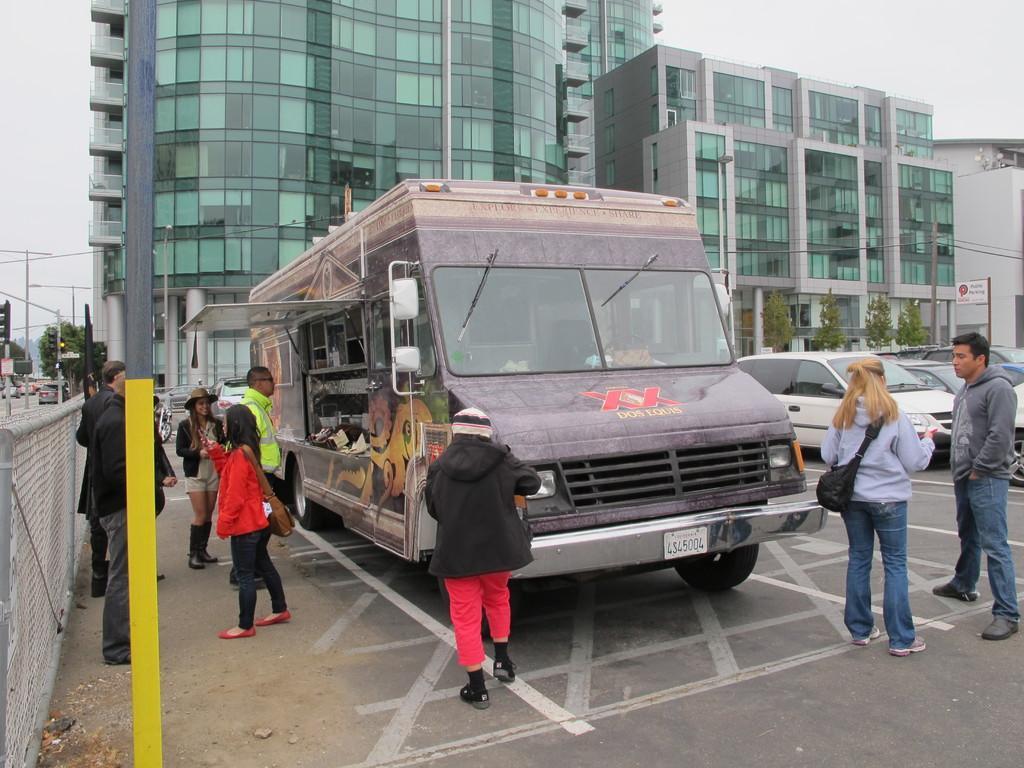Can you describe this image briefly? In this image we can see these people are standing on the road, we can see a food truck, a few vehicles parked here, we can see boards, fence, poles, trees, traffic signal poles, glass buildings and the sky in the background. 